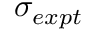<formula> <loc_0><loc_0><loc_500><loc_500>\sigma _ { e x p t }</formula> 